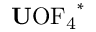Convert formula to latex. <formula><loc_0><loc_0><loc_500><loc_500>{ U } O F _ { 4 } ^ { * }</formula> 